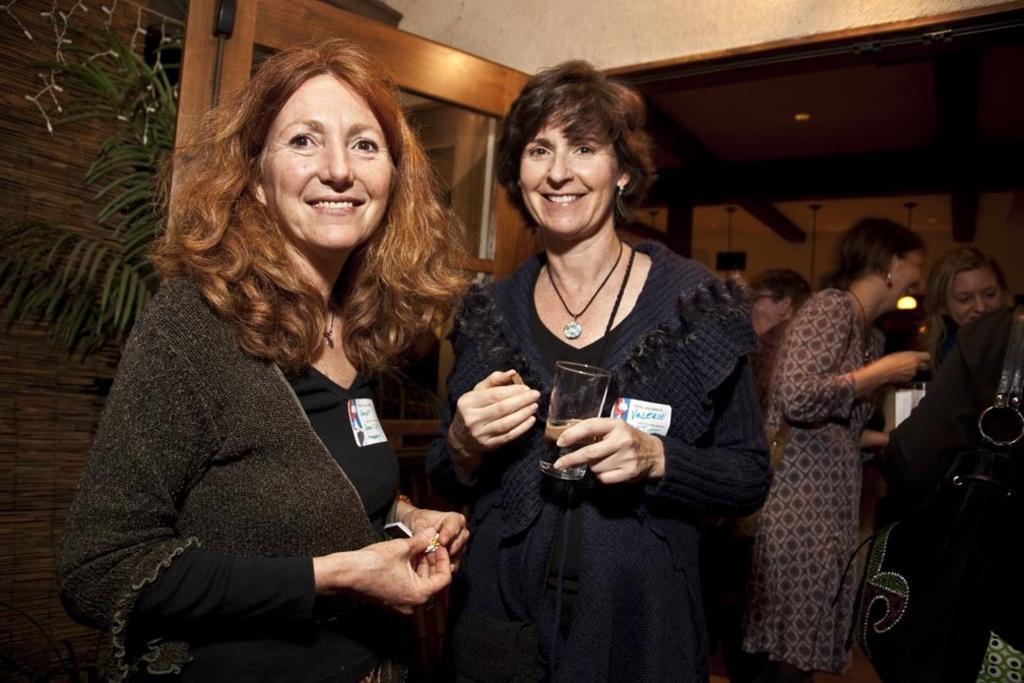Describe this image in one or two sentences. In this picture I can see two persons standing and smiling, there is a person holding a glass, there is a house plant, there are string lights, there is a door, and in the background there are group of people standing. 